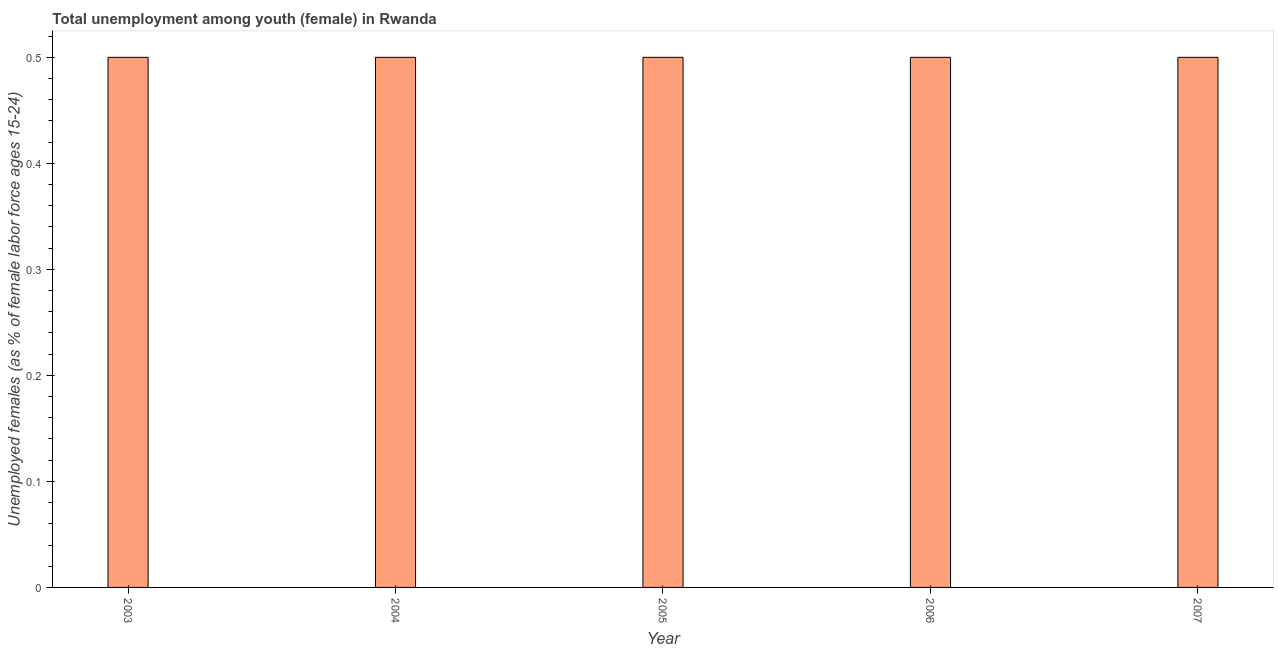Does the graph contain any zero values?
Make the answer very short. No. Does the graph contain grids?
Your response must be concise. No. What is the title of the graph?
Provide a succinct answer. Total unemployment among youth (female) in Rwanda. What is the label or title of the X-axis?
Offer a very short reply. Year. What is the label or title of the Y-axis?
Provide a short and direct response. Unemployed females (as % of female labor force ages 15-24). Across all years, what is the maximum unemployed female youth population?
Keep it short and to the point. 0.5. Across all years, what is the minimum unemployed female youth population?
Your answer should be compact. 0.5. In which year was the unemployed female youth population minimum?
Make the answer very short. 2003. What is the sum of the unemployed female youth population?
Your answer should be very brief. 2.5. What is the difference between the unemployed female youth population in 2004 and 2007?
Make the answer very short. 0. What is the average unemployed female youth population per year?
Offer a terse response. 0.5. What is the median unemployed female youth population?
Provide a short and direct response. 0.5. In how many years, is the unemployed female youth population greater than 0.1 %?
Provide a short and direct response. 5. Do a majority of the years between 2003 and 2006 (inclusive) have unemployed female youth population greater than 0.48 %?
Keep it short and to the point. Yes. What is the ratio of the unemployed female youth population in 2004 to that in 2006?
Your response must be concise. 1. What is the difference between the highest and the second highest unemployed female youth population?
Your answer should be compact. 0. What is the difference between the highest and the lowest unemployed female youth population?
Provide a short and direct response. 0. In how many years, is the unemployed female youth population greater than the average unemployed female youth population taken over all years?
Give a very brief answer. 0. How many years are there in the graph?
Your response must be concise. 5. What is the difference between two consecutive major ticks on the Y-axis?
Make the answer very short. 0.1. What is the Unemployed females (as % of female labor force ages 15-24) in 2003?
Your answer should be compact. 0.5. What is the Unemployed females (as % of female labor force ages 15-24) of 2004?
Your answer should be compact. 0.5. What is the Unemployed females (as % of female labor force ages 15-24) of 2006?
Your response must be concise. 0.5. What is the Unemployed females (as % of female labor force ages 15-24) of 2007?
Provide a short and direct response. 0.5. What is the difference between the Unemployed females (as % of female labor force ages 15-24) in 2003 and 2004?
Offer a very short reply. 0. What is the difference between the Unemployed females (as % of female labor force ages 15-24) in 2003 and 2005?
Ensure brevity in your answer.  0. What is the difference between the Unemployed females (as % of female labor force ages 15-24) in 2003 and 2007?
Provide a succinct answer. 0. What is the difference between the Unemployed females (as % of female labor force ages 15-24) in 2004 and 2006?
Offer a terse response. 0. What is the ratio of the Unemployed females (as % of female labor force ages 15-24) in 2003 to that in 2005?
Your answer should be very brief. 1. What is the ratio of the Unemployed females (as % of female labor force ages 15-24) in 2003 to that in 2006?
Offer a terse response. 1. What is the ratio of the Unemployed females (as % of female labor force ages 15-24) in 2003 to that in 2007?
Make the answer very short. 1. What is the ratio of the Unemployed females (as % of female labor force ages 15-24) in 2005 to that in 2006?
Keep it short and to the point. 1. What is the ratio of the Unemployed females (as % of female labor force ages 15-24) in 2005 to that in 2007?
Offer a very short reply. 1. 